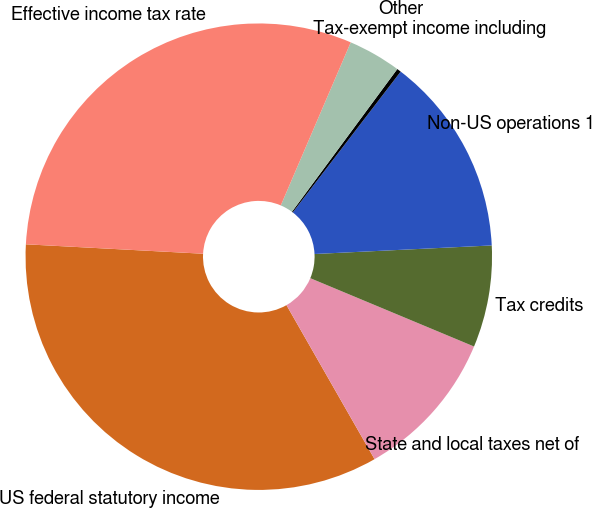Convert chart. <chart><loc_0><loc_0><loc_500><loc_500><pie_chart><fcel>US federal statutory income<fcel>State and local taxes net of<fcel>Tax credits<fcel>Non-US operations 1<fcel>Tax-exempt income including<fcel>Other<fcel>Effective income tax rate<nl><fcel>34.11%<fcel>10.44%<fcel>7.06%<fcel>13.82%<fcel>0.29%<fcel>3.67%<fcel>30.6%<nl></chart> 